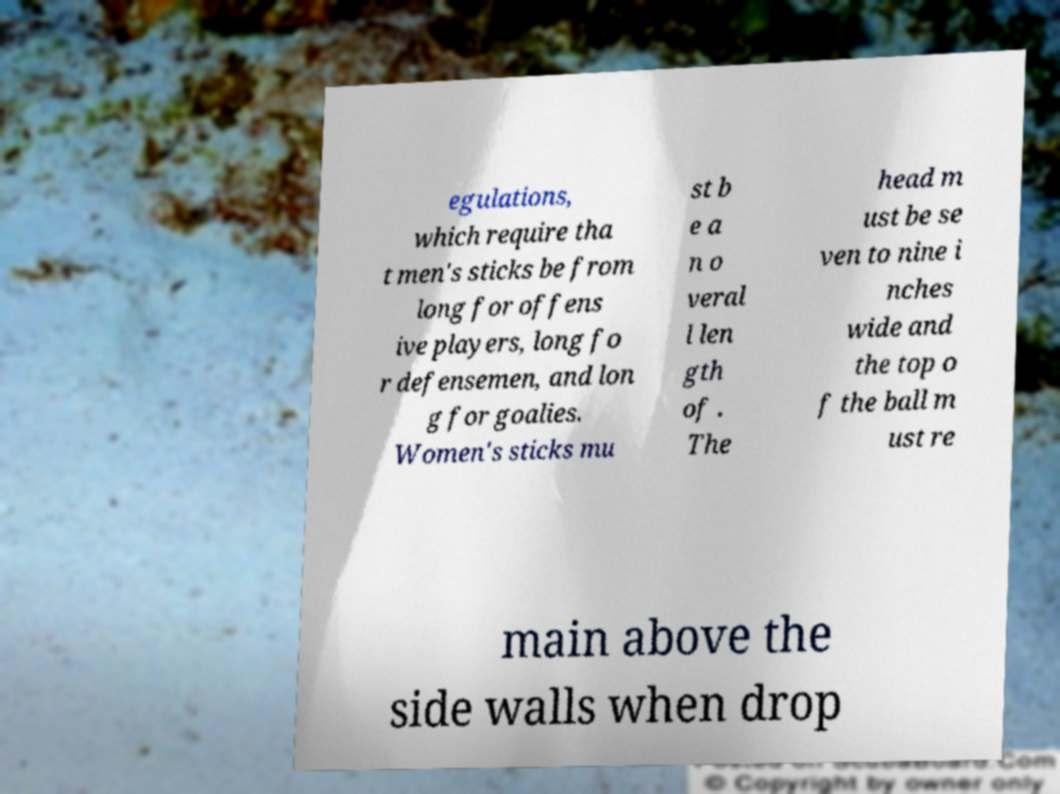For documentation purposes, I need the text within this image transcribed. Could you provide that? egulations, which require tha t men's sticks be from long for offens ive players, long fo r defensemen, and lon g for goalies. Women's sticks mu st b e a n o veral l len gth of . The head m ust be se ven to nine i nches wide and the top o f the ball m ust re main above the side walls when drop 